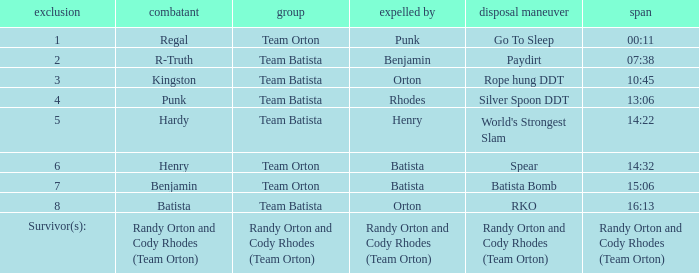Which wrestling participant belongs to team batista, who was knocked out by orton at elimination 8? Batista. 